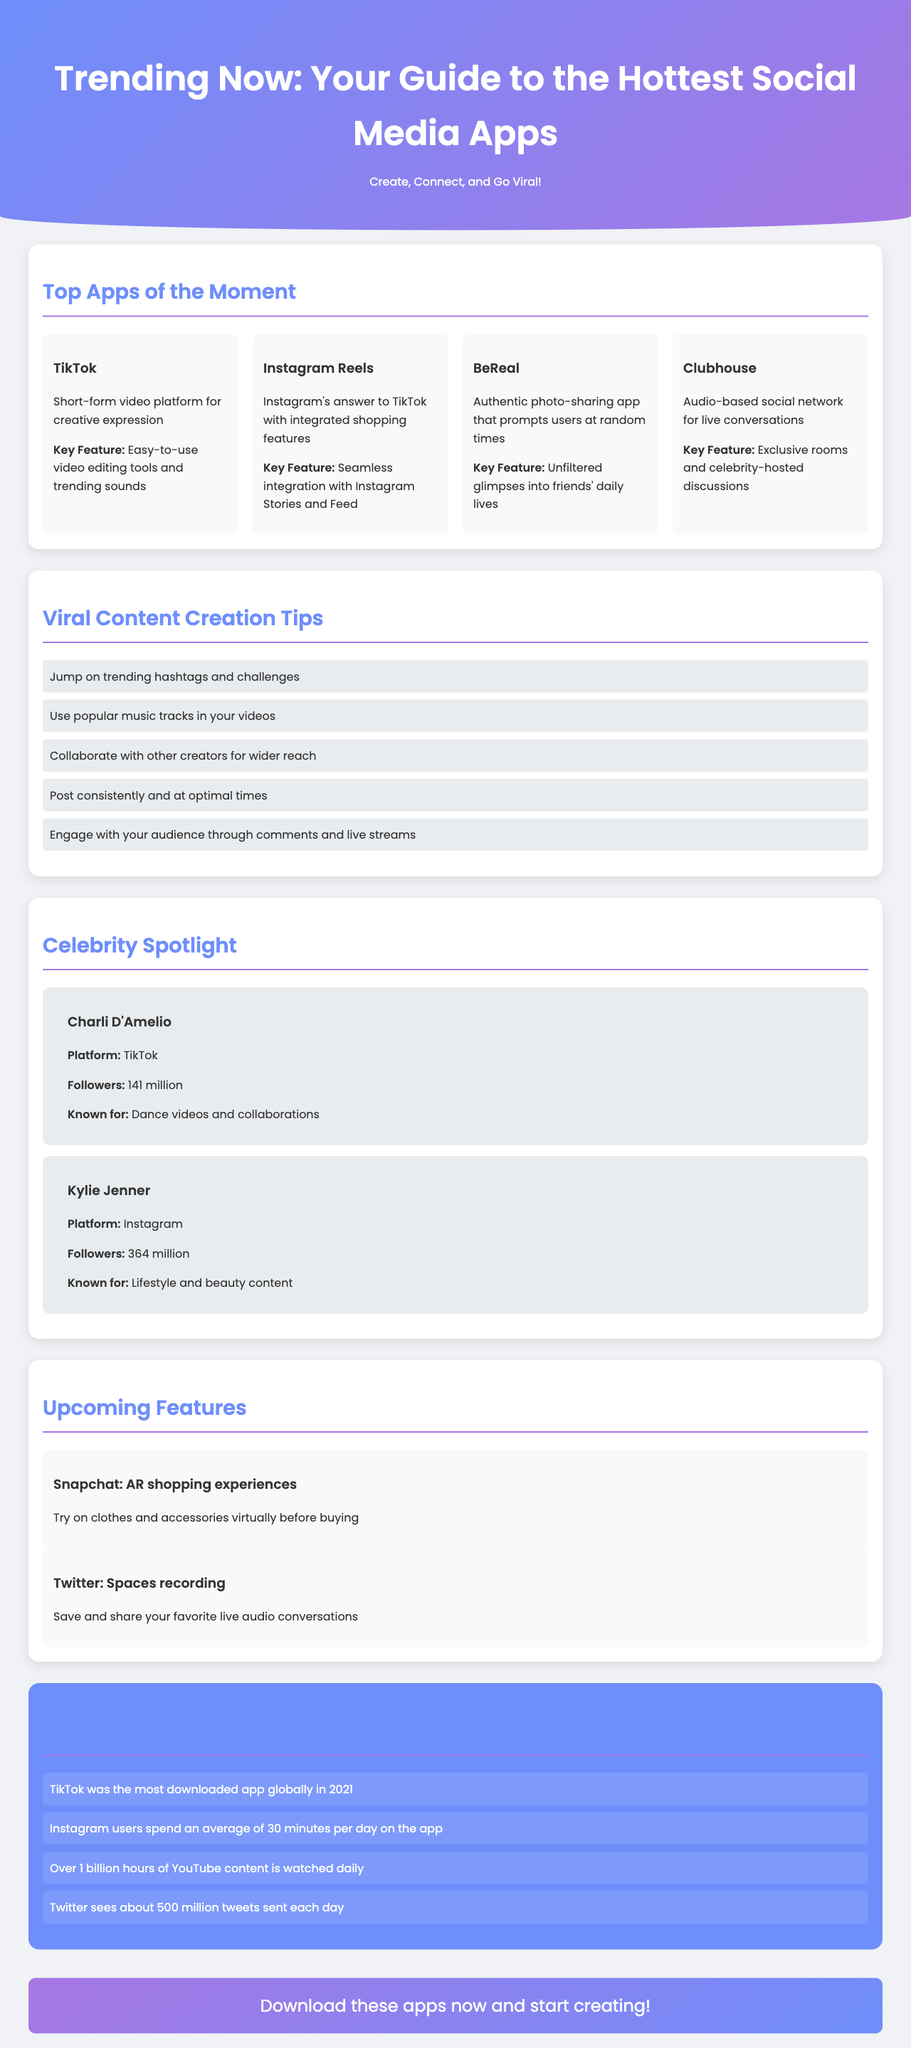What is the title of the brochure? The title is presented at the top of the document and describes the main theme of the content within.
Answer: Trending Now: Your Guide to the Hottest Social Media Apps Which app is known for its short-form video content? This information is captured in the section discussing the top apps and highlights their main features.
Answer: TikTok How many followers does Kylie Jenner have? This specific number is listed under the celebrity spotlight, detailing her social media influence.
Answer: 364 million What feature is upcoming for Snapchat? The document mentions specific future features for various apps, including Snapchat's innovative offerings.
Answer: AR shopping experiences What is a tip for creating viral content? The tips provided are key strategies for gaining popularity on social media platforms.
Answer: Jump on trending hashtags and challenges Which app prompts users randomly for photo-sharing? The description of each app highlights unique functionalities, and this one is noted for its randomness.
Answer: BeReal How many users actively spend time on Instagram daily? This information relates to user engagement and is provided as a fun fact in the document.
Answer: 30 minutes What type of content is Charli D'Amelio known for? This question focuses on the celebrities highlighted in the brochure and their popular content type.
Answer: Dance videos and collaborations What color scheme is used in the header section? The brochure layout design is reflected in its color choices, particularly in the header.
Answer: Gradient of blue and purple 